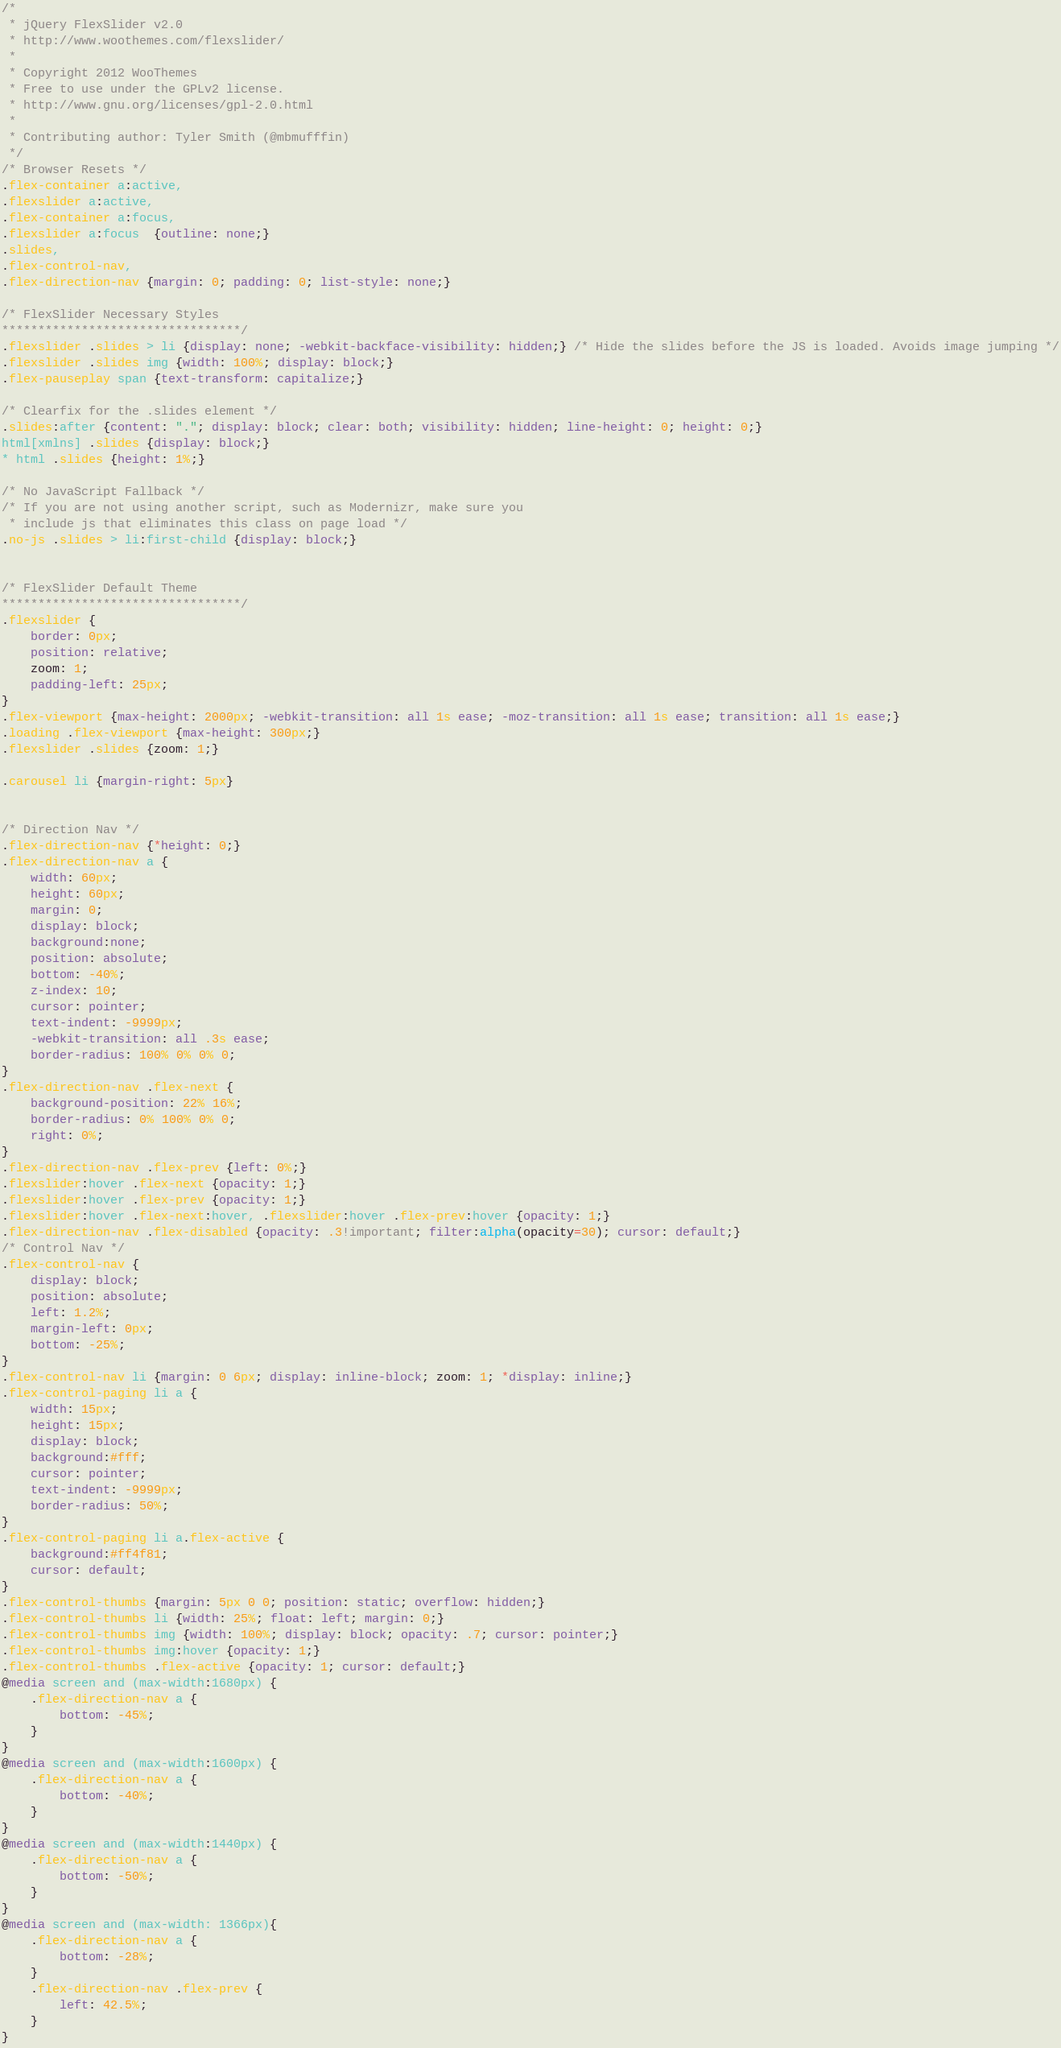Convert code to text. <code><loc_0><loc_0><loc_500><loc_500><_CSS_>/*
 * jQuery FlexSlider v2.0
 * http://www.woothemes.com/flexslider/
 *
 * Copyright 2012 WooThemes
 * Free to use under the GPLv2 license.
 * http://www.gnu.org/licenses/gpl-2.0.html
 *
 * Contributing author: Tyler Smith (@mbmufffin)
 */
/* Browser Resets */
.flex-container a:active,
.flexslider a:active,
.flex-container a:focus,
.flexslider a:focus  {outline: none;}
.slides,
.flex-control-nav,
.flex-direction-nav {margin: 0; padding: 0; list-style: none;} 

/* FlexSlider Necessary Styles
*********************************/ 
.flexslider .slides > li {display: none; -webkit-backface-visibility: hidden;} /* Hide the slides before the JS is loaded. Avoids image jumping */
.flexslider .slides img {width: 100%; display: block;}
.flex-pauseplay span {text-transform: capitalize;}

/* Clearfix for the .slides element */
.slides:after {content: "."; display: block; clear: both; visibility: hidden; line-height: 0; height: 0;} 
html[xmlns] .slides {display: block;} 
* html .slides {height: 1%;}

/* No JavaScript Fallback */
/* If you are not using another script, such as Modernizr, make sure you
 * include js that eliminates this class on page load */
.no-js .slides > li:first-child {display: block;}


/* FlexSlider Default Theme
*********************************/
.flexslider {
	border: 0px;
	position: relative;
	zoom: 1;
	padding-left: 25px;
}
.flex-viewport {max-height: 2000px; -webkit-transition: all 1s ease; -moz-transition: all 1s ease; transition: all 1s ease;}
.loading .flex-viewport {max-height: 300px;}
.flexslider .slides {zoom: 1;}

.carousel li {margin-right: 5px}


/* Direction Nav */
.flex-direction-nav {*height: 0;}
.flex-direction-nav a {
	width: 60px;
    height: 60px;
    margin: 0;
    display: block;
    background:none;
    position: absolute;
    bottom: -40%;
    z-index: 10;
    cursor: pointer;
    text-indent: -9999px;
    -webkit-transition: all .3s ease;
    border-radius: 100% 0% 0% 0;
}
.flex-direction-nav .flex-next {
	background-position: 22% 16%;
    border-radius: 0% 100% 0% 0;
    right: 0%;
}
.flex-direction-nav .flex-prev {left: 0%;}
.flexslider:hover .flex-next {opacity: 1;}
.flexslider:hover .flex-prev {opacity: 1;}
.flexslider:hover .flex-next:hover, .flexslider:hover .flex-prev:hover {opacity: 1;}
.flex-direction-nav .flex-disabled {opacity: .3!important; filter:alpha(opacity=30); cursor: default;}
/* Control Nav */
.flex-control-nav {
    display: block;
    position: absolute;
    left: 1.2%;
    margin-left: 0px;
    bottom: -25%;
}
.flex-control-nav li {margin: 0 6px; display: inline-block; zoom: 1; *display: inline;}
.flex-control-paging li a {
	width: 15px;
    height: 15px;
    display: block;
    background:#fff;
    cursor: pointer;
    text-indent: -9999px;
	border-radius: 50%;
}
.flex-control-paging li a.flex-active { 
	background:#ff4f81;
    cursor: default;
}
.flex-control-thumbs {margin: 5px 0 0; position: static; overflow: hidden;}
.flex-control-thumbs li {width: 25%; float: left; margin: 0;}
.flex-control-thumbs img {width: 100%; display: block; opacity: .7; cursor: pointer;}
.flex-control-thumbs img:hover {opacity: 1;}
.flex-control-thumbs .flex-active {opacity: 1; cursor: default;}
@media screen and (max-width:1680px) {
	.flex-direction-nav a {
		bottom: -45%;
	}
}
@media screen and (max-width:1600px) {
	.flex-direction-nav a {
		bottom: -40%;
	}
}
@media screen and (max-width:1440px) {
	.flex-direction-nav a {
		bottom: -50%;
	}
}
@media screen and (max-width: 1366px){
	.flex-direction-nav a {
		bottom: -28%;
	}
	.flex-direction-nav .flex-prev {
		left: 42.5%;
	}
}</code> 